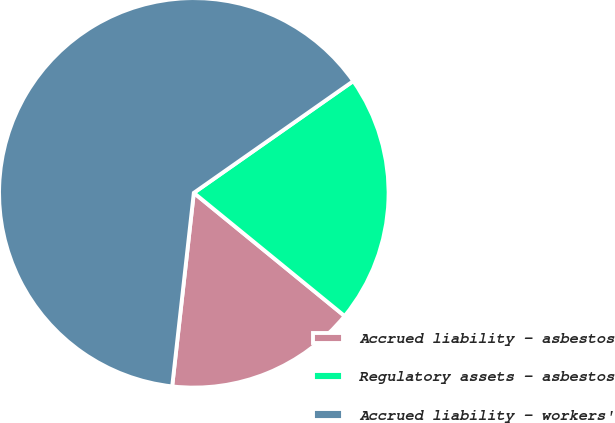Convert chart. <chart><loc_0><loc_0><loc_500><loc_500><pie_chart><fcel>Accrued liability - asbestos<fcel>Regulatory assets - asbestos<fcel>Accrued liability - workers'<nl><fcel>15.87%<fcel>20.63%<fcel>63.49%<nl></chart> 